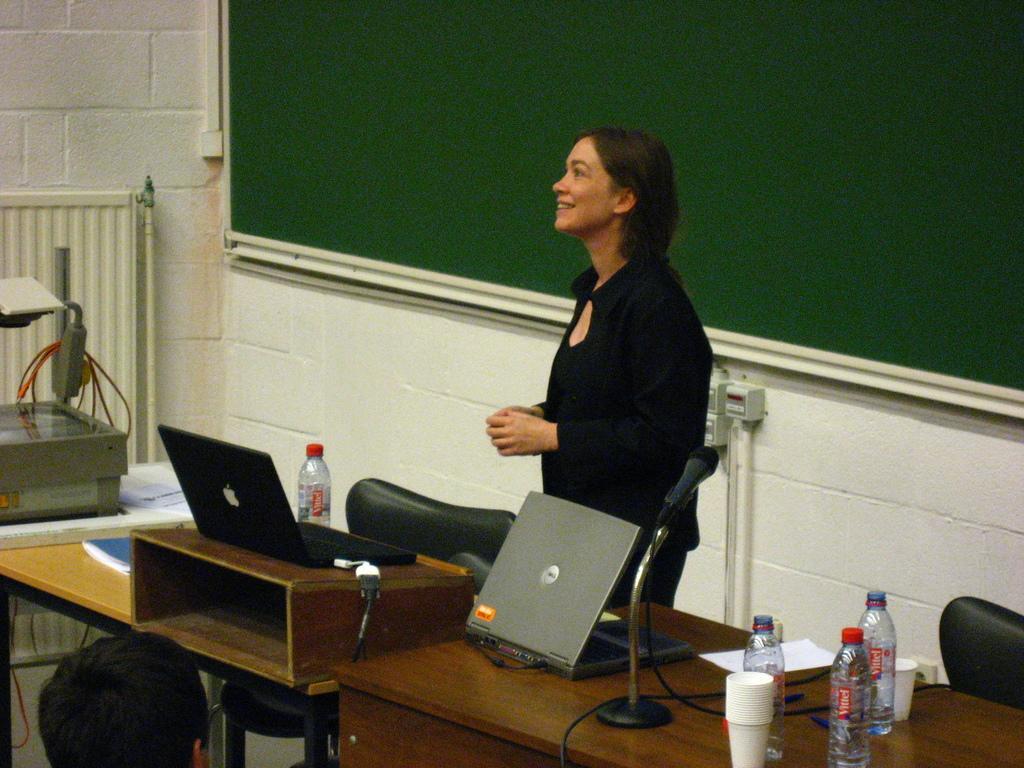How would you summarize this image in a sentence or two? There is a woman standing behind the table and smiling. There are laptops, bottles, microphone, wires, cups and book on the table. There is black board at the back of the women, there is a person sitting opposite to the women. 